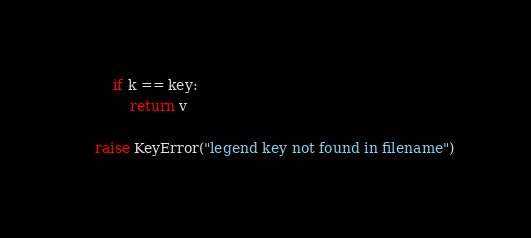<code> <loc_0><loc_0><loc_500><loc_500><_Python_>        if k == key:
            return v

    raise KeyError("legend key not found in filename")
</code> 